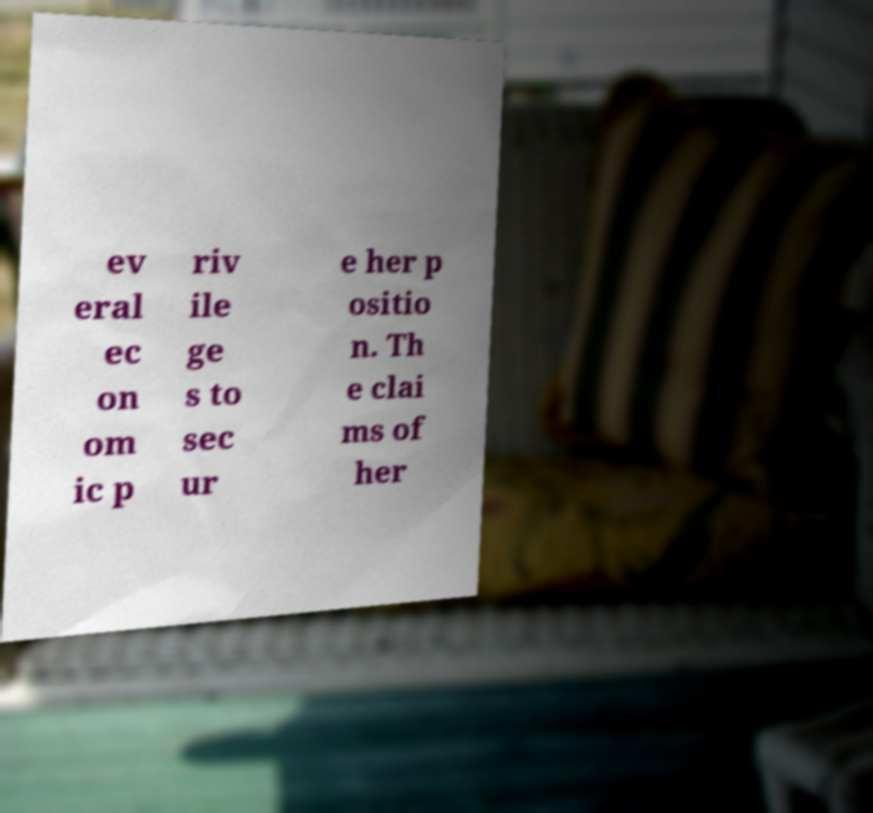I need the written content from this picture converted into text. Can you do that? ev eral ec on om ic p riv ile ge s to sec ur e her p ositio n. Th e clai ms of her 